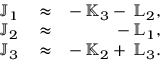<formula> <loc_0><loc_0><loc_500><loc_500>\begin{array} { r l r } { { \mathbb { J } } _ { 1 } } & \approx } & { - \, { \mathbb { K } } _ { 3 } - \, { \mathbb { L } } _ { 2 } , } \\ { { \mathbb { J } } _ { 2 } } & \approx } & { - \, { \mathbb { L } } _ { 1 } , } \\ { { \mathbb { J } } _ { 3 } } & \approx } & { - \, { \mathbb { K } } _ { 2 } + \, { \mathbb { L } } _ { 3 } . } \end{array}</formula> 